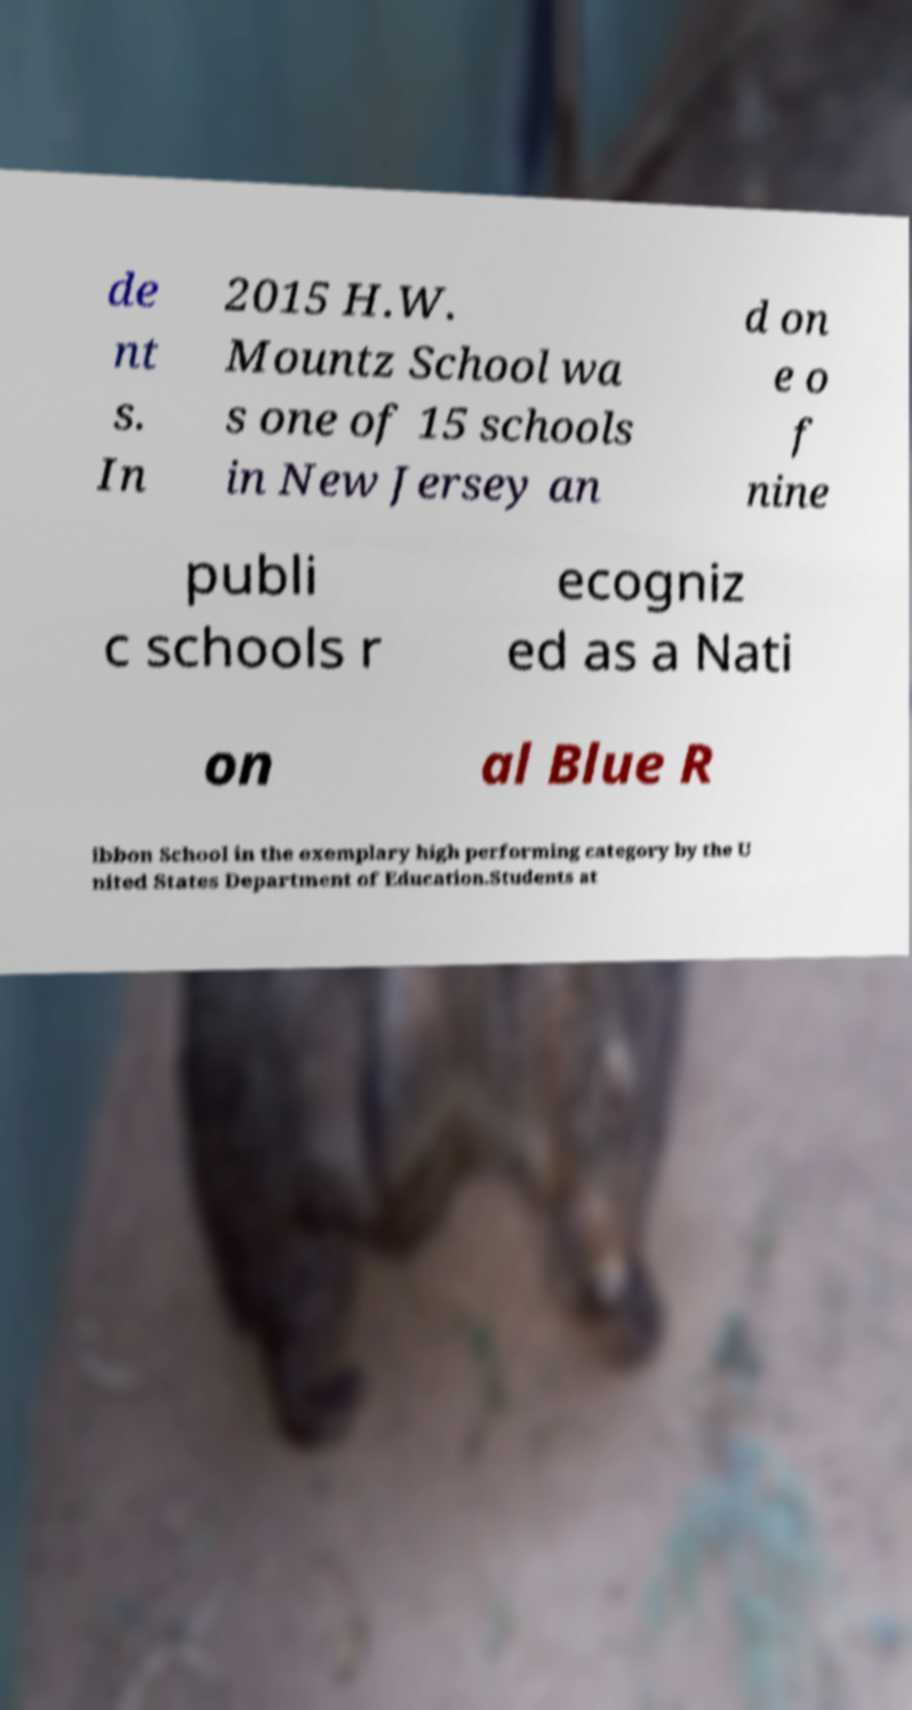Could you extract and type out the text from this image? de nt s. In 2015 H.W. Mountz School wa s one of 15 schools in New Jersey an d on e o f nine publi c schools r ecogniz ed as a Nati on al Blue R ibbon School in the exemplary high performing category by the U nited States Department of Education.Students at 